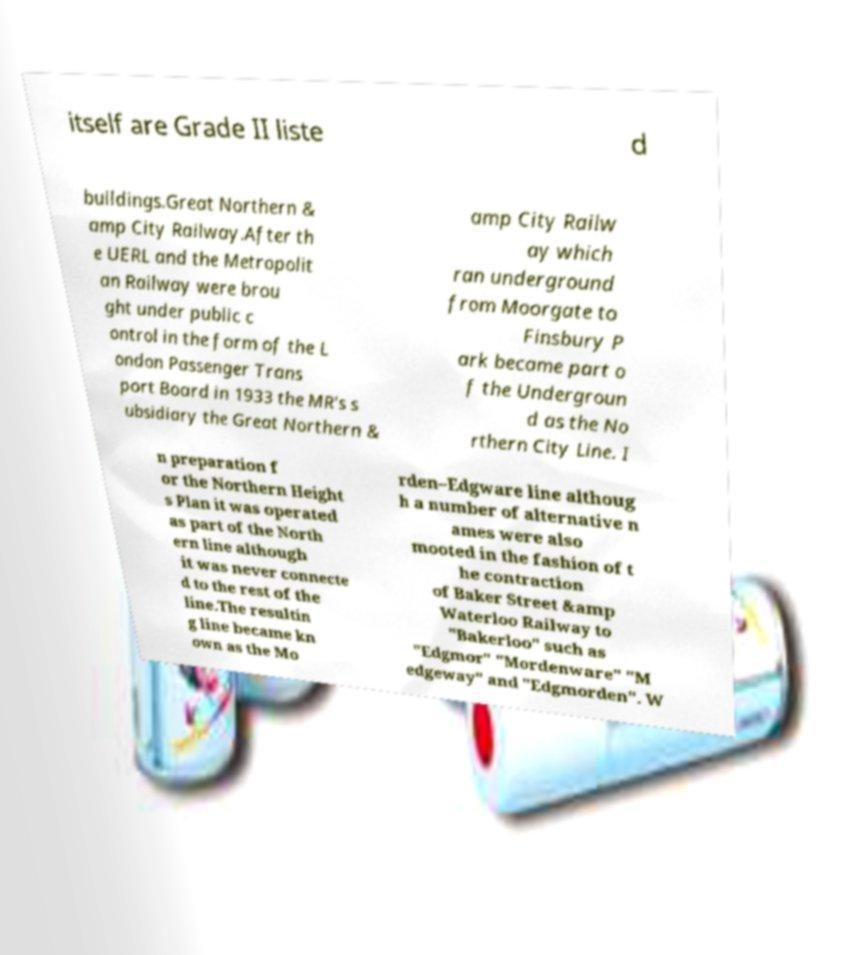Could you extract and type out the text from this image? itself are Grade II liste d buildings.Great Northern & amp City Railway.After th e UERL and the Metropolit an Railway were brou ght under public c ontrol in the form of the L ondon Passenger Trans port Board in 1933 the MR's s ubsidiary the Great Northern & amp City Railw ay which ran underground from Moorgate to Finsbury P ark became part o f the Undergroun d as the No rthern City Line. I n preparation f or the Northern Height s Plan it was operated as part of the North ern line although it was never connecte d to the rest of the line.The resultin g line became kn own as the Mo rden–Edgware line althoug h a number of alternative n ames were also mooted in the fashion of t he contraction of Baker Street &amp Waterloo Railway to "Bakerloo" such as "Edgmor" "Mordenware" "M edgeway" and "Edgmorden". W 